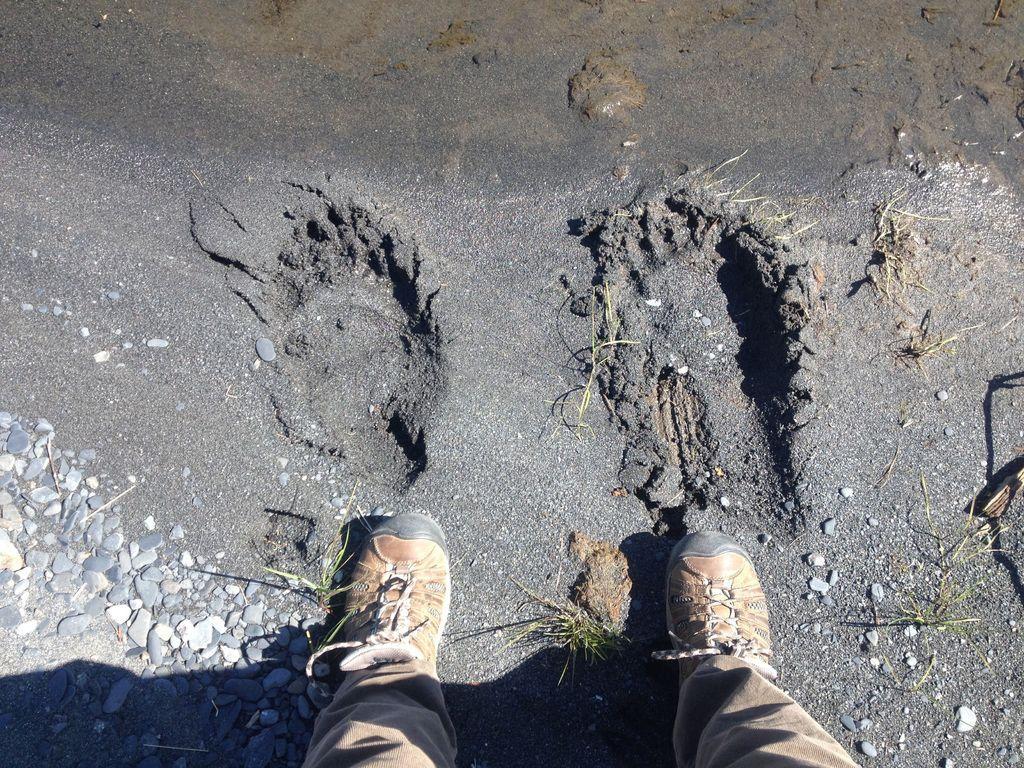Could you give a brief overview of what you see in this image? At the bottom of the picture, we see the grass and the legs of the person who is wearing a brown pant and the brown shoes. In the left bottom, we see the stones. In the background, we see the grass and the soil in black color. 